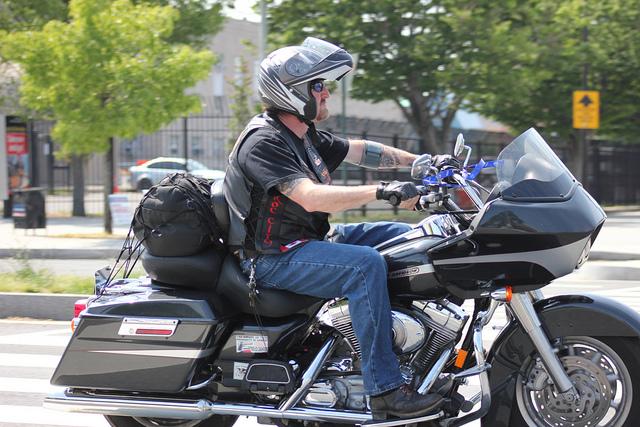What is the man on?
Short answer required. Motorcycle. Can this man arrest someone?
Be succinct. No. Which way does the black arrow point?
Give a very brief answer. Up. What color is the man's bike?
Short answer required. Black. How many people are on the bike?
Concise answer only. 1. 